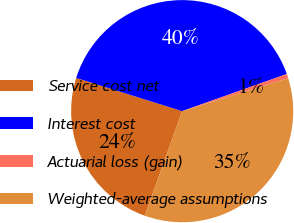<chart> <loc_0><loc_0><loc_500><loc_500><pie_chart><fcel>Service cost net<fcel>Interest cost<fcel>Actuarial loss (gain)<fcel>Weighted-average assumptions<nl><fcel>24.36%<fcel>39.74%<fcel>0.64%<fcel>35.26%<nl></chart> 